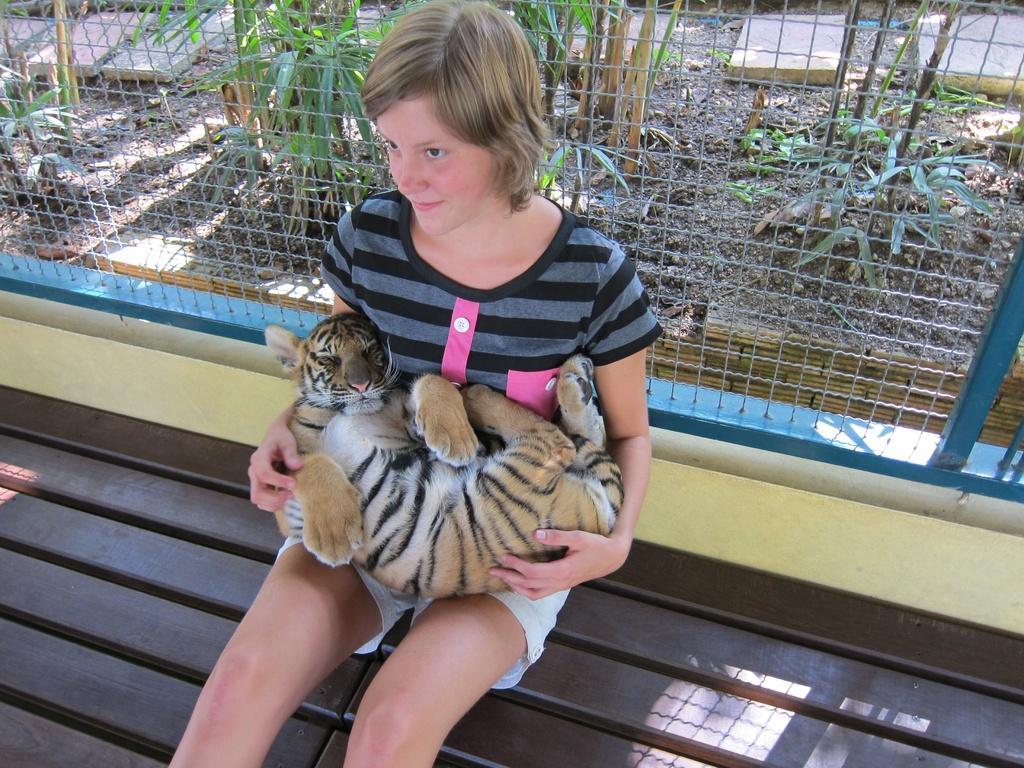Can you describe this image briefly? In the middle a girl is sitting on the wooden bench holding a tiger in her lap behind her it's an iron fencing. 